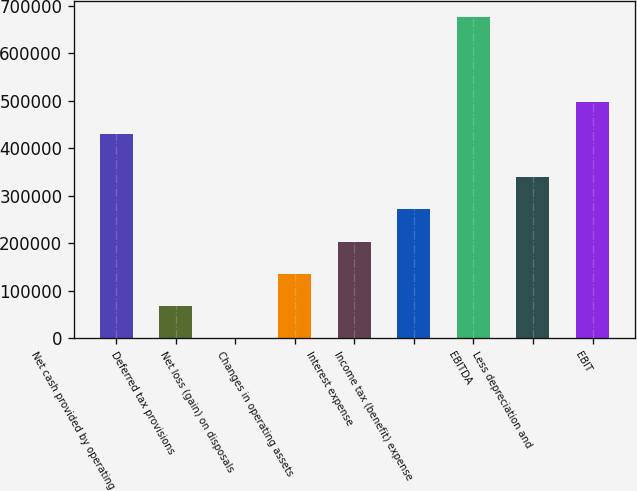Convert chart. <chart><loc_0><loc_0><loc_500><loc_500><bar_chart><fcel>Net cash provided by operating<fcel>Deferred tax provisions<fcel>Net loss (gain) on disposals<fcel>Changes in operating assets<fcel>Interest expense<fcel>Income tax (benefit) expense<fcel>EBITDA<fcel>Less depreciation and<fcel>EBIT<nl><fcel>430354<fcel>67851.9<fcel>149<fcel>135555<fcel>203258<fcel>270961<fcel>677178<fcel>338664<fcel>498057<nl></chart> 